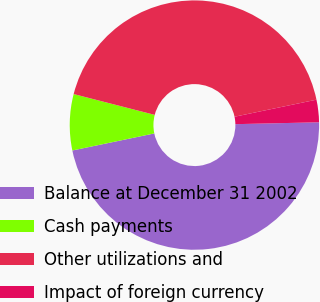<chart> <loc_0><loc_0><loc_500><loc_500><pie_chart><fcel>Balance at December 31 2002<fcel>Cash payments<fcel>Other utilizations and<fcel>Impact of foreign currency<nl><fcel>47.09%<fcel>7.27%<fcel>42.73%<fcel>2.91%<nl></chart> 